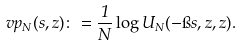<formula> <loc_0><loc_0><loc_500><loc_500>\ v p _ { N } ( s , z ) \colon = \frac { 1 } { N } \log U _ { N } ( - \i s , z , z ) .</formula> 